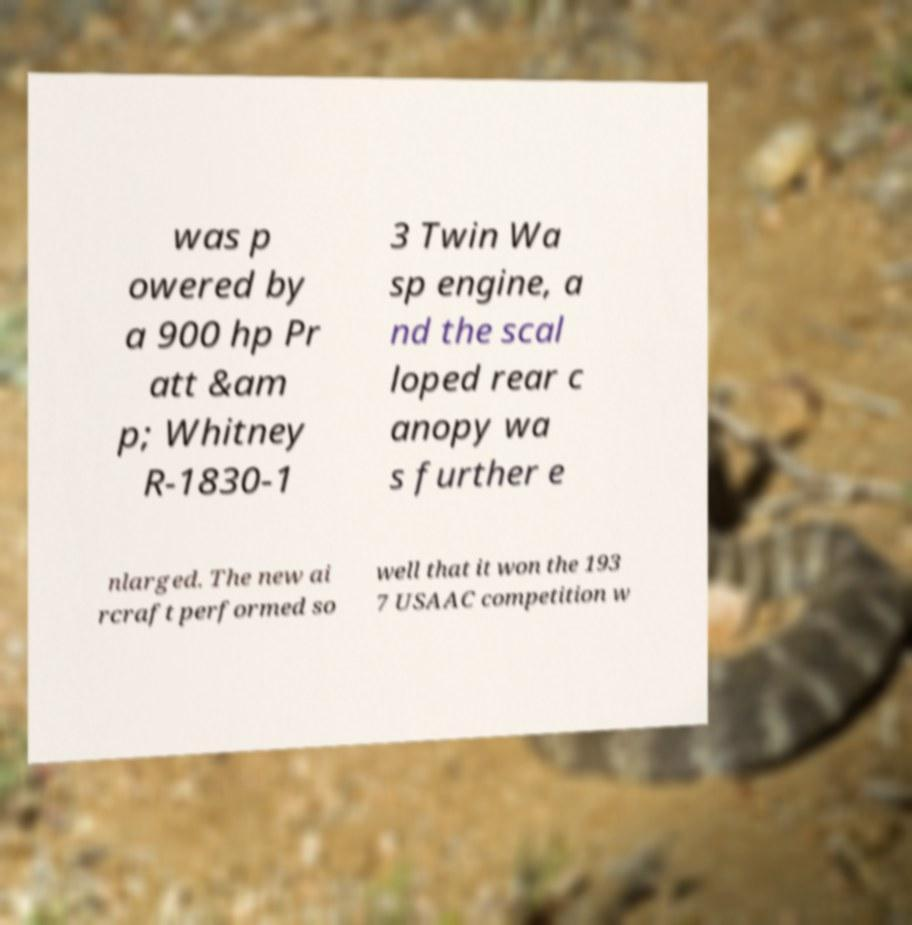For documentation purposes, I need the text within this image transcribed. Could you provide that? was p owered by a 900 hp Pr att &am p; Whitney R-1830-1 3 Twin Wa sp engine, a nd the scal loped rear c anopy wa s further e nlarged. The new ai rcraft performed so well that it won the 193 7 USAAC competition w 